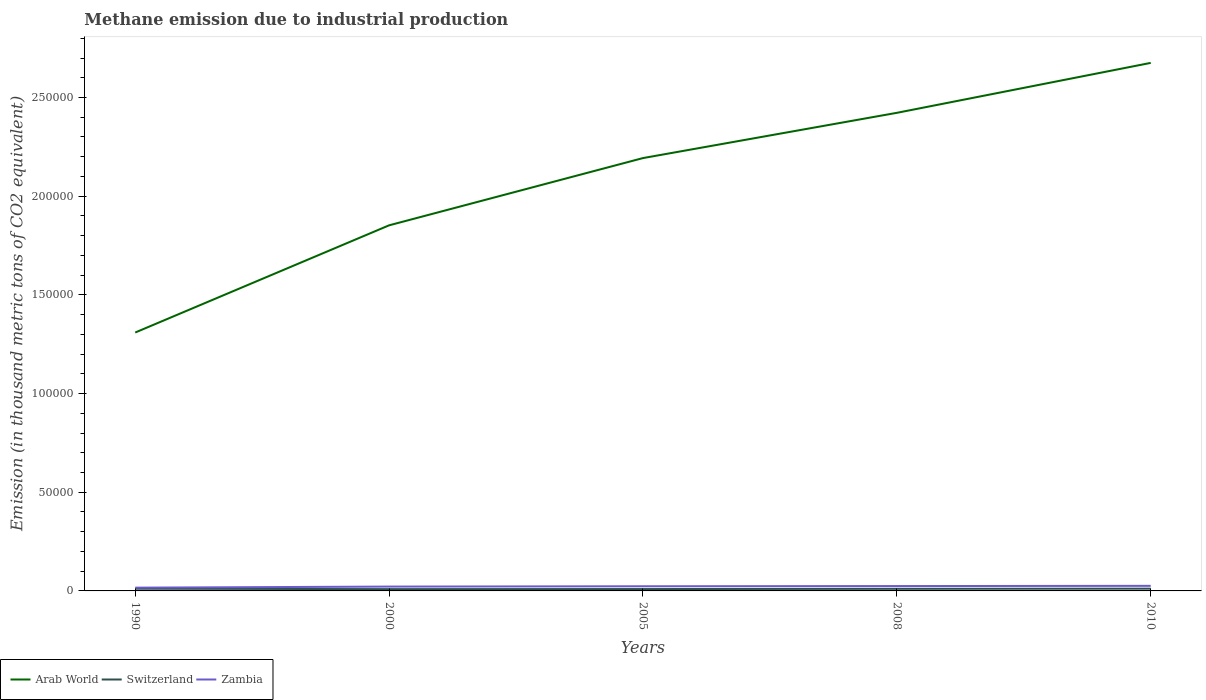Is the number of lines equal to the number of legend labels?
Provide a short and direct response. Yes. Across all years, what is the maximum amount of methane emitted in Switzerland?
Provide a succinct answer. 911.6. What is the total amount of methane emitted in Arab World in the graph?
Offer a very short reply. -1.11e+05. What is the difference between the highest and the second highest amount of methane emitted in Switzerland?
Ensure brevity in your answer.  238.6. Is the amount of methane emitted in Arab World strictly greater than the amount of methane emitted in Zambia over the years?
Give a very brief answer. No. How many lines are there?
Offer a very short reply. 3. What is the difference between two consecutive major ticks on the Y-axis?
Keep it short and to the point. 5.00e+04. Are the values on the major ticks of Y-axis written in scientific E-notation?
Your response must be concise. No. Does the graph contain any zero values?
Your answer should be very brief. No. How many legend labels are there?
Make the answer very short. 3. How are the legend labels stacked?
Provide a succinct answer. Horizontal. What is the title of the graph?
Make the answer very short. Methane emission due to industrial production. What is the label or title of the Y-axis?
Provide a short and direct response. Emission (in thousand metric tons of CO2 equivalent). What is the Emission (in thousand metric tons of CO2 equivalent) of Arab World in 1990?
Your response must be concise. 1.31e+05. What is the Emission (in thousand metric tons of CO2 equivalent) of Switzerland in 1990?
Provide a short and direct response. 1112.7. What is the Emission (in thousand metric tons of CO2 equivalent) of Zambia in 1990?
Offer a terse response. 1655.8. What is the Emission (in thousand metric tons of CO2 equivalent) of Arab World in 2000?
Provide a short and direct response. 1.85e+05. What is the Emission (in thousand metric tons of CO2 equivalent) of Switzerland in 2000?
Your answer should be very brief. 911.6. What is the Emission (in thousand metric tons of CO2 equivalent) of Zambia in 2000?
Offer a terse response. 2197.5. What is the Emission (in thousand metric tons of CO2 equivalent) of Arab World in 2005?
Offer a very short reply. 2.19e+05. What is the Emission (in thousand metric tons of CO2 equivalent) in Switzerland in 2005?
Ensure brevity in your answer.  948.6. What is the Emission (in thousand metric tons of CO2 equivalent) in Zambia in 2005?
Your answer should be very brief. 2355. What is the Emission (in thousand metric tons of CO2 equivalent) of Arab World in 2008?
Ensure brevity in your answer.  2.42e+05. What is the Emission (in thousand metric tons of CO2 equivalent) in Switzerland in 2008?
Offer a terse response. 1068.1. What is the Emission (in thousand metric tons of CO2 equivalent) of Zambia in 2008?
Ensure brevity in your answer.  2464.9. What is the Emission (in thousand metric tons of CO2 equivalent) of Arab World in 2010?
Keep it short and to the point. 2.68e+05. What is the Emission (in thousand metric tons of CO2 equivalent) in Switzerland in 2010?
Your answer should be compact. 1150.2. What is the Emission (in thousand metric tons of CO2 equivalent) in Zambia in 2010?
Offer a very short reply. 2574.7. Across all years, what is the maximum Emission (in thousand metric tons of CO2 equivalent) in Arab World?
Offer a very short reply. 2.68e+05. Across all years, what is the maximum Emission (in thousand metric tons of CO2 equivalent) of Switzerland?
Your answer should be compact. 1150.2. Across all years, what is the maximum Emission (in thousand metric tons of CO2 equivalent) of Zambia?
Offer a terse response. 2574.7. Across all years, what is the minimum Emission (in thousand metric tons of CO2 equivalent) of Arab World?
Keep it short and to the point. 1.31e+05. Across all years, what is the minimum Emission (in thousand metric tons of CO2 equivalent) in Switzerland?
Make the answer very short. 911.6. Across all years, what is the minimum Emission (in thousand metric tons of CO2 equivalent) in Zambia?
Your answer should be very brief. 1655.8. What is the total Emission (in thousand metric tons of CO2 equivalent) in Arab World in the graph?
Ensure brevity in your answer.  1.05e+06. What is the total Emission (in thousand metric tons of CO2 equivalent) in Switzerland in the graph?
Your response must be concise. 5191.2. What is the total Emission (in thousand metric tons of CO2 equivalent) in Zambia in the graph?
Give a very brief answer. 1.12e+04. What is the difference between the Emission (in thousand metric tons of CO2 equivalent) in Arab World in 1990 and that in 2000?
Your response must be concise. -5.43e+04. What is the difference between the Emission (in thousand metric tons of CO2 equivalent) of Switzerland in 1990 and that in 2000?
Ensure brevity in your answer.  201.1. What is the difference between the Emission (in thousand metric tons of CO2 equivalent) in Zambia in 1990 and that in 2000?
Make the answer very short. -541.7. What is the difference between the Emission (in thousand metric tons of CO2 equivalent) in Arab World in 1990 and that in 2005?
Your answer should be compact. -8.84e+04. What is the difference between the Emission (in thousand metric tons of CO2 equivalent) in Switzerland in 1990 and that in 2005?
Your response must be concise. 164.1. What is the difference between the Emission (in thousand metric tons of CO2 equivalent) in Zambia in 1990 and that in 2005?
Your response must be concise. -699.2. What is the difference between the Emission (in thousand metric tons of CO2 equivalent) in Arab World in 1990 and that in 2008?
Provide a succinct answer. -1.11e+05. What is the difference between the Emission (in thousand metric tons of CO2 equivalent) in Switzerland in 1990 and that in 2008?
Give a very brief answer. 44.6. What is the difference between the Emission (in thousand metric tons of CO2 equivalent) of Zambia in 1990 and that in 2008?
Offer a terse response. -809.1. What is the difference between the Emission (in thousand metric tons of CO2 equivalent) in Arab World in 1990 and that in 2010?
Offer a terse response. -1.37e+05. What is the difference between the Emission (in thousand metric tons of CO2 equivalent) of Switzerland in 1990 and that in 2010?
Make the answer very short. -37.5. What is the difference between the Emission (in thousand metric tons of CO2 equivalent) of Zambia in 1990 and that in 2010?
Ensure brevity in your answer.  -918.9. What is the difference between the Emission (in thousand metric tons of CO2 equivalent) in Arab World in 2000 and that in 2005?
Make the answer very short. -3.41e+04. What is the difference between the Emission (in thousand metric tons of CO2 equivalent) of Switzerland in 2000 and that in 2005?
Make the answer very short. -37. What is the difference between the Emission (in thousand metric tons of CO2 equivalent) of Zambia in 2000 and that in 2005?
Offer a terse response. -157.5. What is the difference between the Emission (in thousand metric tons of CO2 equivalent) of Arab World in 2000 and that in 2008?
Offer a very short reply. -5.70e+04. What is the difference between the Emission (in thousand metric tons of CO2 equivalent) in Switzerland in 2000 and that in 2008?
Offer a terse response. -156.5. What is the difference between the Emission (in thousand metric tons of CO2 equivalent) in Zambia in 2000 and that in 2008?
Give a very brief answer. -267.4. What is the difference between the Emission (in thousand metric tons of CO2 equivalent) of Arab World in 2000 and that in 2010?
Offer a terse response. -8.23e+04. What is the difference between the Emission (in thousand metric tons of CO2 equivalent) in Switzerland in 2000 and that in 2010?
Your answer should be very brief. -238.6. What is the difference between the Emission (in thousand metric tons of CO2 equivalent) of Zambia in 2000 and that in 2010?
Ensure brevity in your answer.  -377.2. What is the difference between the Emission (in thousand metric tons of CO2 equivalent) of Arab World in 2005 and that in 2008?
Offer a terse response. -2.29e+04. What is the difference between the Emission (in thousand metric tons of CO2 equivalent) in Switzerland in 2005 and that in 2008?
Your response must be concise. -119.5. What is the difference between the Emission (in thousand metric tons of CO2 equivalent) of Zambia in 2005 and that in 2008?
Offer a very short reply. -109.9. What is the difference between the Emission (in thousand metric tons of CO2 equivalent) in Arab World in 2005 and that in 2010?
Make the answer very short. -4.82e+04. What is the difference between the Emission (in thousand metric tons of CO2 equivalent) of Switzerland in 2005 and that in 2010?
Provide a short and direct response. -201.6. What is the difference between the Emission (in thousand metric tons of CO2 equivalent) in Zambia in 2005 and that in 2010?
Keep it short and to the point. -219.7. What is the difference between the Emission (in thousand metric tons of CO2 equivalent) of Arab World in 2008 and that in 2010?
Give a very brief answer. -2.53e+04. What is the difference between the Emission (in thousand metric tons of CO2 equivalent) in Switzerland in 2008 and that in 2010?
Ensure brevity in your answer.  -82.1. What is the difference between the Emission (in thousand metric tons of CO2 equivalent) of Zambia in 2008 and that in 2010?
Your answer should be very brief. -109.8. What is the difference between the Emission (in thousand metric tons of CO2 equivalent) in Arab World in 1990 and the Emission (in thousand metric tons of CO2 equivalent) in Switzerland in 2000?
Provide a short and direct response. 1.30e+05. What is the difference between the Emission (in thousand metric tons of CO2 equivalent) in Arab World in 1990 and the Emission (in thousand metric tons of CO2 equivalent) in Zambia in 2000?
Ensure brevity in your answer.  1.29e+05. What is the difference between the Emission (in thousand metric tons of CO2 equivalent) of Switzerland in 1990 and the Emission (in thousand metric tons of CO2 equivalent) of Zambia in 2000?
Keep it short and to the point. -1084.8. What is the difference between the Emission (in thousand metric tons of CO2 equivalent) in Arab World in 1990 and the Emission (in thousand metric tons of CO2 equivalent) in Switzerland in 2005?
Ensure brevity in your answer.  1.30e+05. What is the difference between the Emission (in thousand metric tons of CO2 equivalent) in Arab World in 1990 and the Emission (in thousand metric tons of CO2 equivalent) in Zambia in 2005?
Offer a very short reply. 1.29e+05. What is the difference between the Emission (in thousand metric tons of CO2 equivalent) of Switzerland in 1990 and the Emission (in thousand metric tons of CO2 equivalent) of Zambia in 2005?
Your answer should be very brief. -1242.3. What is the difference between the Emission (in thousand metric tons of CO2 equivalent) of Arab World in 1990 and the Emission (in thousand metric tons of CO2 equivalent) of Switzerland in 2008?
Your answer should be compact. 1.30e+05. What is the difference between the Emission (in thousand metric tons of CO2 equivalent) in Arab World in 1990 and the Emission (in thousand metric tons of CO2 equivalent) in Zambia in 2008?
Offer a terse response. 1.28e+05. What is the difference between the Emission (in thousand metric tons of CO2 equivalent) of Switzerland in 1990 and the Emission (in thousand metric tons of CO2 equivalent) of Zambia in 2008?
Your answer should be very brief. -1352.2. What is the difference between the Emission (in thousand metric tons of CO2 equivalent) of Arab World in 1990 and the Emission (in thousand metric tons of CO2 equivalent) of Switzerland in 2010?
Provide a succinct answer. 1.30e+05. What is the difference between the Emission (in thousand metric tons of CO2 equivalent) of Arab World in 1990 and the Emission (in thousand metric tons of CO2 equivalent) of Zambia in 2010?
Provide a succinct answer. 1.28e+05. What is the difference between the Emission (in thousand metric tons of CO2 equivalent) of Switzerland in 1990 and the Emission (in thousand metric tons of CO2 equivalent) of Zambia in 2010?
Ensure brevity in your answer.  -1462. What is the difference between the Emission (in thousand metric tons of CO2 equivalent) in Arab World in 2000 and the Emission (in thousand metric tons of CO2 equivalent) in Switzerland in 2005?
Offer a terse response. 1.84e+05. What is the difference between the Emission (in thousand metric tons of CO2 equivalent) in Arab World in 2000 and the Emission (in thousand metric tons of CO2 equivalent) in Zambia in 2005?
Offer a terse response. 1.83e+05. What is the difference between the Emission (in thousand metric tons of CO2 equivalent) of Switzerland in 2000 and the Emission (in thousand metric tons of CO2 equivalent) of Zambia in 2005?
Ensure brevity in your answer.  -1443.4. What is the difference between the Emission (in thousand metric tons of CO2 equivalent) in Arab World in 2000 and the Emission (in thousand metric tons of CO2 equivalent) in Switzerland in 2008?
Your answer should be compact. 1.84e+05. What is the difference between the Emission (in thousand metric tons of CO2 equivalent) of Arab World in 2000 and the Emission (in thousand metric tons of CO2 equivalent) of Zambia in 2008?
Keep it short and to the point. 1.83e+05. What is the difference between the Emission (in thousand metric tons of CO2 equivalent) in Switzerland in 2000 and the Emission (in thousand metric tons of CO2 equivalent) in Zambia in 2008?
Provide a short and direct response. -1553.3. What is the difference between the Emission (in thousand metric tons of CO2 equivalent) of Arab World in 2000 and the Emission (in thousand metric tons of CO2 equivalent) of Switzerland in 2010?
Your response must be concise. 1.84e+05. What is the difference between the Emission (in thousand metric tons of CO2 equivalent) of Arab World in 2000 and the Emission (in thousand metric tons of CO2 equivalent) of Zambia in 2010?
Ensure brevity in your answer.  1.83e+05. What is the difference between the Emission (in thousand metric tons of CO2 equivalent) in Switzerland in 2000 and the Emission (in thousand metric tons of CO2 equivalent) in Zambia in 2010?
Your answer should be compact. -1663.1. What is the difference between the Emission (in thousand metric tons of CO2 equivalent) of Arab World in 2005 and the Emission (in thousand metric tons of CO2 equivalent) of Switzerland in 2008?
Provide a succinct answer. 2.18e+05. What is the difference between the Emission (in thousand metric tons of CO2 equivalent) of Arab World in 2005 and the Emission (in thousand metric tons of CO2 equivalent) of Zambia in 2008?
Provide a short and direct response. 2.17e+05. What is the difference between the Emission (in thousand metric tons of CO2 equivalent) of Switzerland in 2005 and the Emission (in thousand metric tons of CO2 equivalent) of Zambia in 2008?
Offer a terse response. -1516.3. What is the difference between the Emission (in thousand metric tons of CO2 equivalent) in Arab World in 2005 and the Emission (in thousand metric tons of CO2 equivalent) in Switzerland in 2010?
Your answer should be compact. 2.18e+05. What is the difference between the Emission (in thousand metric tons of CO2 equivalent) in Arab World in 2005 and the Emission (in thousand metric tons of CO2 equivalent) in Zambia in 2010?
Your answer should be compact. 2.17e+05. What is the difference between the Emission (in thousand metric tons of CO2 equivalent) in Switzerland in 2005 and the Emission (in thousand metric tons of CO2 equivalent) in Zambia in 2010?
Your response must be concise. -1626.1. What is the difference between the Emission (in thousand metric tons of CO2 equivalent) of Arab World in 2008 and the Emission (in thousand metric tons of CO2 equivalent) of Switzerland in 2010?
Offer a terse response. 2.41e+05. What is the difference between the Emission (in thousand metric tons of CO2 equivalent) in Arab World in 2008 and the Emission (in thousand metric tons of CO2 equivalent) in Zambia in 2010?
Ensure brevity in your answer.  2.40e+05. What is the difference between the Emission (in thousand metric tons of CO2 equivalent) in Switzerland in 2008 and the Emission (in thousand metric tons of CO2 equivalent) in Zambia in 2010?
Give a very brief answer. -1506.6. What is the average Emission (in thousand metric tons of CO2 equivalent) of Arab World per year?
Offer a terse response. 2.09e+05. What is the average Emission (in thousand metric tons of CO2 equivalent) of Switzerland per year?
Provide a short and direct response. 1038.24. What is the average Emission (in thousand metric tons of CO2 equivalent) of Zambia per year?
Offer a very short reply. 2249.58. In the year 1990, what is the difference between the Emission (in thousand metric tons of CO2 equivalent) of Arab World and Emission (in thousand metric tons of CO2 equivalent) of Switzerland?
Your answer should be very brief. 1.30e+05. In the year 1990, what is the difference between the Emission (in thousand metric tons of CO2 equivalent) in Arab World and Emission (in thousand metric tons of CO2 equivalent) in Zambia?
Your response must be concise. 1.29e+05. In the year 1990, what is the difference between the Emission (in thousand metric tons of CO2 equivalent) of Switzerland and Emission (in thousand metric tons of CO2 equivalent) of Zambia?
Provide a succinct answer. -543.1. In the year 2000, what is the difference between the Emission (in thousand metric tons of CO2 equivalent) in Arab World and Emission (in thousand metric tons of CO2 equivalent) in Switzerland?
Your answer should be compact. 1.84e+05. In the year 2000, what is the difference between the Emission (in thousand metric tons of CO2 equivalent) of Arab World and Emission (in thousand metric tons of CO2 equivalent) of Zambia?
Keep it short and to the point. 1.83e+05. In the year 2000, what is the difference between the Emission (in thousand metric tons of CO2 equivalent) in Switzerland and Emission (in thousand metric tons of CO2 equivalent) in Zambia?
Ensure brevity in your answer.  -1285.9. In the year 2005, what is the difference between the Emission (in thousand metric tons of CO2 equivalent) of Arab World and Emission (in thousand metric tons of CO2 equivalent) of Switzerland?
Give a very brief answer. 2.18e+05. In the year 2005, what is the difference between the Emission (in thousand metric tons of CO2 equivalent) in Arab World and Emission (in thousand metric tons of CO2 equivalent) in Zambia?
Offer a terse response. 2.17e+05. In the year 2005, what is the difference between the Emission (in thousand metric tons of CO2 equivalent) of Switzerland and Emission (in thousand metric tons of CO2 equivalent) of Zambia?
Ensure brevity in your answer.  -1406.4. In the year 2008, what is the difference between the Emission (in thousand metric tons of CO2 equivalent) of Arab World and Emission (in thousand metric tons of CO2 equivalent) of Switzerland?
Your answer should be compact. 2.41e+05. In the year 2008, what is the difference between the Emission (in thousand metric tons of CO2 equivalent) of Arab World and Emission (in thousand metric tons of CO2 equivalent) of Zambia?
Your response must be concise. 2.40e+05. In the year 2008, what is the difference between the Emission (in thousand metric tons of CO2 equivalent) of Switzerland and Emission (in thousand metric tons of CO2 equivalent) of Zambia?
Provide a succinct answer. -1396.8. In the year 2010, what is the difference between the Emission (in thousand metric tons of CO2 equivalent) in Arab World and Emission (in thousand metric tons of CO2 equivalent) in Switzerland?
Your answer should be very brief. 2.66e+05. In the year 2010, what is the difference between the Emission (in thousand metric tons of CO2 equivalent) in Arab World and Emission (in thousand metric tons of CO2 equivalent) in Zambia?
Give a very brief answer. 2.65e+05. In the year 2010, what is the difference between the Emission (in thousand metric tons of CO2 equivalent) of Switzerland and Emission (in thousand metric tons of CO2 equivalent) of Zambia?
Your response must be concise. -1424.5. What is the ratio of the Emission (in thousand metric tons of CO2 equivalent) of Arab World in 1990 to that in 2000?
Your response must be concise. 0.71. What is the ratio of the Emission (in thousand metric tons of CO2 equivalent) of Switzerland in 1990 to that in 2000?
Offer a terse response. 1.22. What is the ratio of the Emission (in thousand metric tons of CO2 equivalent) of Zambia in 1990 to that in 2000?
Your answer should be compact. 0.75. What is the ratio of the Emission (in thousand metric tons of CO2 equivalent) in Arab World in 1990 to that in 2005?
Offer a very short reply. 0.6. What is the ratio of the Emission (in thousand metric tons of CO2 equivalent) in Switzerland in 1990 to that in 2005?
Ensure brevity in your answer.  1.17. What is the ratio of the Emission (in thousand metric tons of CO2 equivalent) in Zambia in 1990 to that in 2005?
Your answer should be very brief. 0.7. What is the ratio of the Emission (in thousand metric tons of CO2 equivalent) in Arab World in 1990 to that in 2008?
Your answer should be very brief. 0.54. What is the ratio of the Emission (in thousand metric tons of CO2 equivalent) of Switzerland in 1990 to that in 2008?
Ensure brevity in your answer.  1.04. What is the ratio of the Emission (in thousand metric tons of CO2 equivalent) of Zambia in 1990 to that in 2008?
Offer a terse response. 0.67. What is the ratio of the Emission (in thousand metric tons of CO2 equivalent) of Arab World in 1990 to that in 2010?
Offer a very short reply. 0.49. What is the ratio of the Emission (in thousand metric tons of CO2 equivalent) of Switzerland in 1990 to that in 2010?
Your response must be concise. 0.97. What is the ratio of the Emission (in thousand metric tons of CO2 equivalent) of Zambia in 1990 to that in 2010?
Make the answer very short. 0.64. What is the ratio of the Emission (in thousand metric tons of CO2 equivalent) of Arab World in 2000 to that in 2005?
Ensure brevity in your answer.  0.84. What is the ratio of the Emission (in thousand metric tons of CO2 equivalent) of Zambia in 2000 to that in 2005?
Your response must be concise. 0.93. What is the ratio of the Emission (in thousand metric tons of CO2 equivalent) in Arab World in 2000 to that in 2008?
Ensure brevity in your answer.  0.76. What is the ratio of the Emission (in thousand metric tons of CO2 equivalent) of Switzerland in 2000 to that in 2008?
Give a very brief answer. 0.85. What is the ratio of the Emission (in thousand metric tons of CO2 equivalent) of Zambia in 2000 to that in 2008?
Keep it short and to the point. 0.89. What is the ratio of the Emission (in thousand metric tons of CO2 equivalent) of Arab World in 2000 to that in 2010?
Provide a succinct answer. 0.69. What is the ratio of the Emission (in thousand metric tons of CO2 equivalent) of Switzerland in 2000 to that in 2010?
Provide a succinct answer. 0.79. What is the ratio of the Emission (in thousand metric tons of CO2 equivalent) in Zambia in 2000 to that in 2010?
Your answer should be compact. 0.85. What is the ratio of the Emission (in thousand metric tons of CO2 equivalent) of Arab World in 2005 to that in 2008?
Make the answer very short. 0.91. What is the ratio of the Emission (in thousand metric tons of CO2 equivalent) in Switzerland in 2005 to that in 2008?
Provide a short and direct response. 0.89. What is the ratio of the Emission (in thousand metric tons of CO2 equivalent) of Zambia in 2005 to that in 2008?
Offer a terse response. 0.96. What is the ratio of the Emission (in thousand metric tons of CO2 equivalent) in Arab World in 2005 to that in 2010?
Give a very brief answer. 0.82. What is the ratio of the Emission (in thousand metric tons of CO2 equivalent) of Switzerland in 2005 to that in 2010?
Offer a terse response. 0.82. What is the ratio of the Emission (in thousand metric tons of CO2 equivalent) in Zambia in 2005 to that in 2010?
Provide a succinct answer. 0.91. What is the ratio of the Emission (in thousand metric tons of CO2 equivalent) of Arab World in 2008 to that in 2010?
Offer a very short reply. 0.91. What is the ratio of the Emission (in thousand metric tons of CO2 equivalent) of Switzerland in 2008 to that in 2010?
Provide a short and direct response. 0.93. What is the ratio of the Emission (in thousand metric tons of CO2 equivalent) of Zambia in 2008 to that in 2010?
Provide a short and direct response. 0.96. What is the difference between the highest and the second highest Emission (in thousand metric tons of CO2 equivalent) in Arab World?
Offer a terse response. 2.53e+04. What is the difference between the highest and the second highest Emission (in thousand metric tons of CO2 equivalent) of Switzerland?
Provide a succinct answer. 37.5. What is the difference between the highest and the second highest Emission (in thousand metric tons of CO2 equivalent) of Zambia?
Make the answer very short. 109.8. What is the difference between the highest and the lowest Emission (in thousand metric tons of CO2 equivalent) in Arab World?
Your answer should be compact. 1.37e+05. What is the difference between the highest and the lowest Emission (in thousand metric tons of CO2 equivalent) in Switzerland?
Your answer should be very brief. 238.6. What is the difference between the highest and the lowest Emission (in thousand metric tons of CO2 equivalent) of Zambia?
Provide a succinct answer. 918.9. 